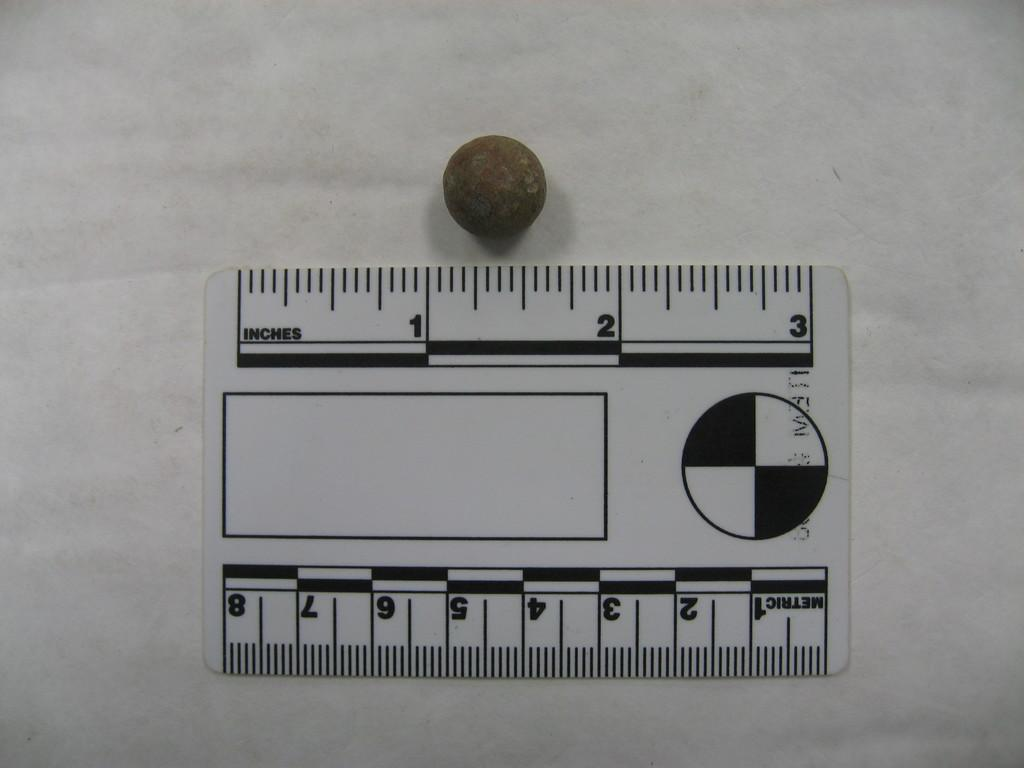<image>
Provide a brief description of the given image. A small black and white ruler states that it can measure in either inches or metric. 